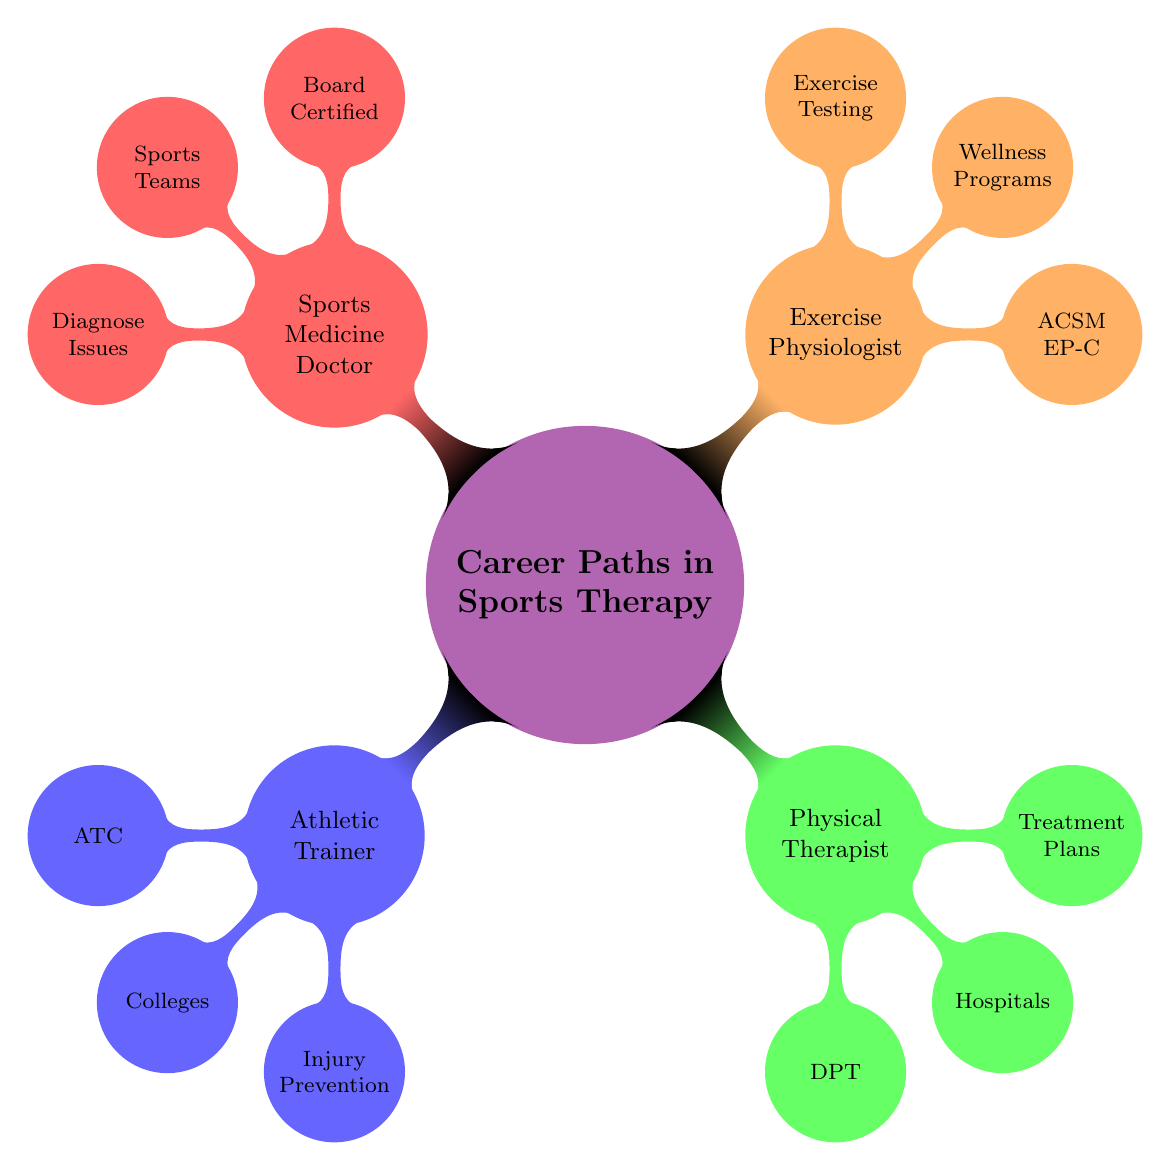What is the certification for an Athletic Trainer? The diagram shows that the certification for an Athletic Trainer is listed as "ATC (Certified Athletic Trainer)" directly under the Athletic Trainer node.
Answer: ATC How many career paths are listed in the diagram? The main node "Career Paths in Sports Therapy" is divided into four child nodes: Athletic Trainer, Physical Therapist, Exercise Physiologist, and Sports Medicine Doctor, making a total of four career paths.
Answer: 4 What is a key responsibility of a Physical Therapist? The diagram lists "Develop Treatment Plans" as one of the key responsibilities under the Physical Therapist node.
Answer: Develop Treatment Plans What is the main work setting for a Sports Medicine Doctor? The diagram indicates that the Sports Medicine Doctor works in several settings, but "Sports Teams" is highlighted as one of their primary work settings under the Sports Medicine Doctor node.
Answer: Sports Teams Which certification does an Exercise Physiologist hold? According to the diagram, the certification for an Exercise Physiologist is "ACSM EP-C (Certified Exercise Physiologist)" under the Exercise Physiologist node.
Answer: ACSM EP-C How does the role of an Athletic Trainer differ from that of a Sports Medicine Doctor? An Athletic Trainer primarily focuses on "Injury Prevention" and "Immediate Care," while a Sports Medicine Doctor is primarily focused on "Diagnose Musculoskeletal Issues" and "Prescribe Treatment," showing a difference in their responsibilities and scope of practice.
Answer: Focus on injuries vs diagnosis In how many work settings does a Physical Therapist operate? The diagram specifies three work settings for a Physical Therapist: Hospitals, Private Practices, and Rehabilitation Centers. Count these settings to determine that the total is three.
Answer: 3 Which career path has a focus on "Exercise Testing"? The diagram indicates that the “Exercise Testing” responsibility is associated with the Exercise Physiologist node, indicating that this career path focuses on exercise testing as part of its responsibilities.
Answer: Exercise Physiologist What type of doctor specializes in Sports Medicine? The diagram specifies that a "Sports Medicine Doctor" is the type of doctor that specializes in Sports Medicine, directly identifiable from the node in the mind map.
Answer: Sports Medicine Doctor 